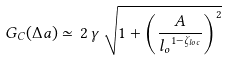Convert formula to latex. <formula><loc_0><loc_0><loc_500><loc_500>G _ { C } ( \Delta a ) \simeq \, 2 \, \gamma \, \sqrt { 1 + \left ( \frac { A } { { l _ { o } } ^ { 1 - { \zeta } _ { l o c } } } \right ) ^ { 2 } }</formula> 